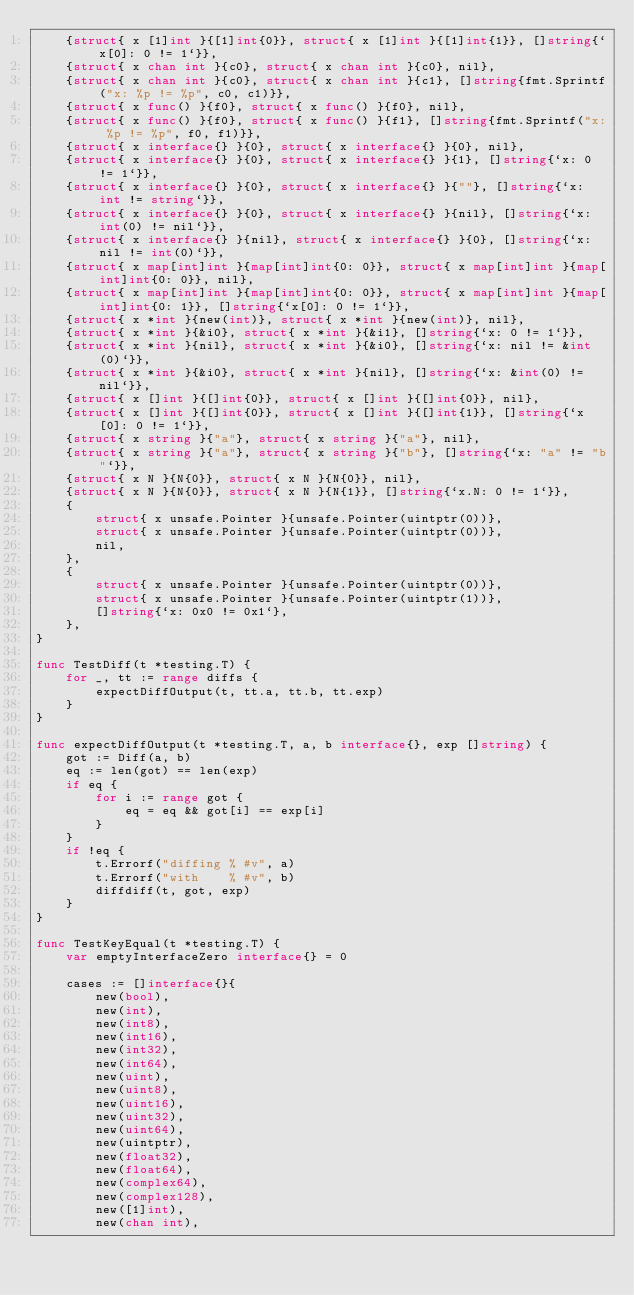<code> <loc_0><loc_0><loc_500><loc_500><_Go_>	{struct{ x [1]int }{[1]int{0}}, struct{ x [1]int }{[1]int{1}}, []string{`x[0]: 0 != 1`}},
	{struct{ x chan int }{c0}, struct{ x chan int }{c0}, nil},
	{struct{ x chan int }{c0}, struct{ x chan int }{c1}, []string{fmt.Sprintf("x: %p != %p", c0, c1)}},
	{struct{ x func() }{f0}, struct{ x func() }{f0}, nil},
	{struct{ x func() }{f0}, struct{ x func() }{f1}, []string{fmt.Sprintf("x: %p != %p", f0, f1)}},
	{struct{ x interface{} }{0}, struct{ x interface{} }{0}, nil},
	{struct{ x interface{} }{0}, struct{ x interface{} }{1}, []string{`x: 0 != 1`}},
	{struct{ x interface{} }{0}, struct{ x interface{} }{""}, []string{`x: int != string`}},
	{struct{ x interface{} }{0}, struct{ x interface{} }{nil}, []string{`x: int(0) != nil`}},
	{struct{ x interface{} }{nil}, struct{ x interface{} }{0}, []string{`x: nil != int(0)`}},
	{struct{ x map[int]int }{map[int]int{0: 0}}, struct{ x map[int]int }{map[int]int{0: 0}}, nil},
	{struct{ x map[int]int }{map[int]int{0: 0}}, struct{ x map[int]int }{map[int]int{0: 1}}, []string{`x[0]: 0 != 1`}},
	{struct{ x *int }{new(int)}, struct{ x *int }{new(int)}, nil},
	{struct{ x *int }{&i0}, struct{ x *int }{&i1}, []string{`x: 0 != 1`}},
	{struct{ x *int }{nil}, struct{ x *int }{&i0}, []string{`x: nil != &int(0)`}},
	{struct{ x *int }{&i0}, struct{ x *int }{nil}, []string{`x: &int(0) != nil`}},
	{struct{ x []int }{[]int{0}}, struct{ x []int }{[]int{0}}, nil},
	{struct{ x []int }{[]int{0}}, struct{ x []int }{[]int{1}}, []string{`x[0]: 0 != 1`}},
	{struct{ x string }{"a"}, struct{ x string }{"a"}, nil},
	{struct{ x string }{"a"}, struct{ x string }{"b"}, []string{`x: "a" != "b"`}},
	{struct{ x N }{N{0}}, struct{ x N }{N{0}}, nil},
	{struct{ x N }{N{0}}, struct{ x N }{N{1}}, []string{`x.N: 0 != 1`}},
	{
		struct{ x unsafe.Pointer }{unsafe.Pointer(uintptr(0))},
		struct{ x unsafe.Pointer }{unsafe.Pointer(uintptr(0))},
		nil,
	},
	{
		struct{ x unsafe.Pointer }{unsafe.Pointer(uintptr(0))},
		struct{ x unsafe.Pointer }{unsafe.Pointer(uintptr(1))},
		[]string{`x: 0x0 != 0x1`},
	},
}

func TestDiff(t *testing.T) {
	for _, tt := range diffs {
		expectDiffOutput(t, tt.a, tt.b, tt.exp)
	}
}

func expectDiffOutput(t *testing.T, a, b interface{}, exp []string) {
	got := Diff(a, b)
	eq := len(got) == len(exp)
	if eq {
		for i := range got {
			eq = eq && got[i] == exp[i]
		}
	}
	if !eq {
		t.Errorf("diffing % #v", a)
		t.Errorf("with    % #v", b)
		diffdiff(t, got, exp)
	}
}

func TestKeyEqual(t *testing.T) {
	var emptyInterfaceZero interface{} = 0

	cases := []interface{}{
		new(bool),
		new(int),
		new(int8),
		new(int16),
		new(int32),
		new(int64),
		new(uint),
		new(uint8),
		new(uint16),
		new(uint32),
		new(uint64),
		new(uintptr),
		new(float32),
		new(float64),
		new(complex64),
		new(complex128),
		new([1]int),
		new(chan int),</code> 